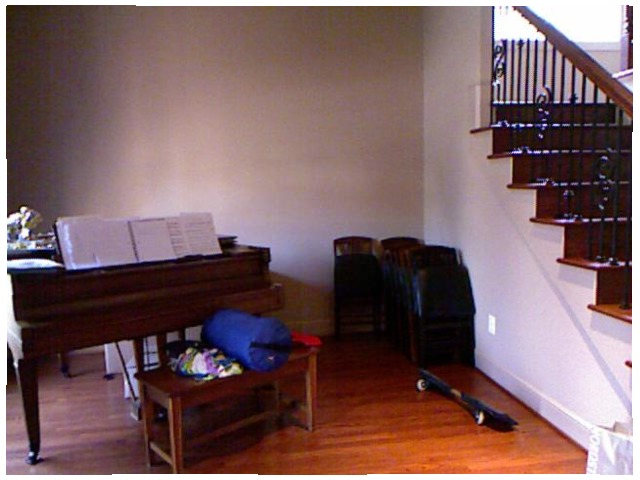<image>
Is the table above the floor? No. The table is not positioned above the floor. The vertical arrangement shows a different relationship. 